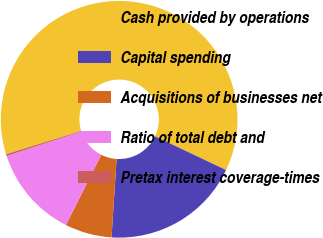Convert chart. <chart><loc_0><loc_0><loc_500><loc_500><pie_chart><fcel>Cash provided by operations<fcel>Capital spending<fcel>Acquisitions of businesses net<fcel>Ratio of total debt and<fcel>Pretax interest coverage-times<nl><fcel>61.81%<fcel>18.97%<fcel>6.4%<fcel>12.56%<fcel>0.25%<nl></chart> 